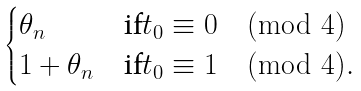<formula> <loc_0><loc_0><loc_500><loc_500>\begin{cases} \theta _ { n } & \text {if} t _ { 0 } \equiv 0 \pmod { 4 } \\ 1 + \theta _ { n } & \text {if} t _ { 0 } \equiv 1 \pmod { 4 } . \end{cases}</formula> 